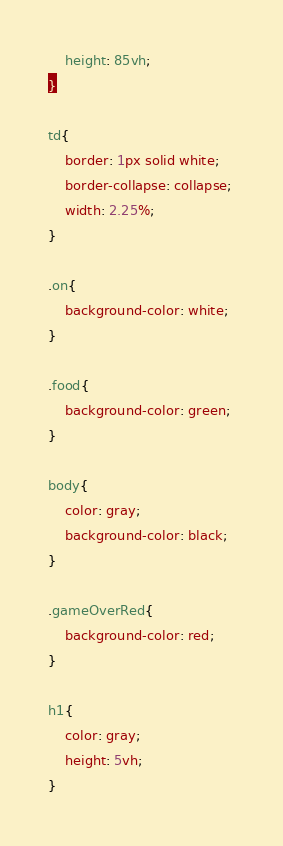<code> <loc_0><loc_0><loc_500><loc_500><_CSS_>    height: 85vh;
}

td{
    border: 1px solid white;
    border-collapse: collapse; 
    width: 2.25%;
}

.on{
    background-color: white;
}

.food{
    background-color: green;
}

body{
    color: gray;
    background-color: black;
}

.gameOverRed{
    background-color: red;
}

h1{
    color: gray;
    height: 5vh;
}</code> 